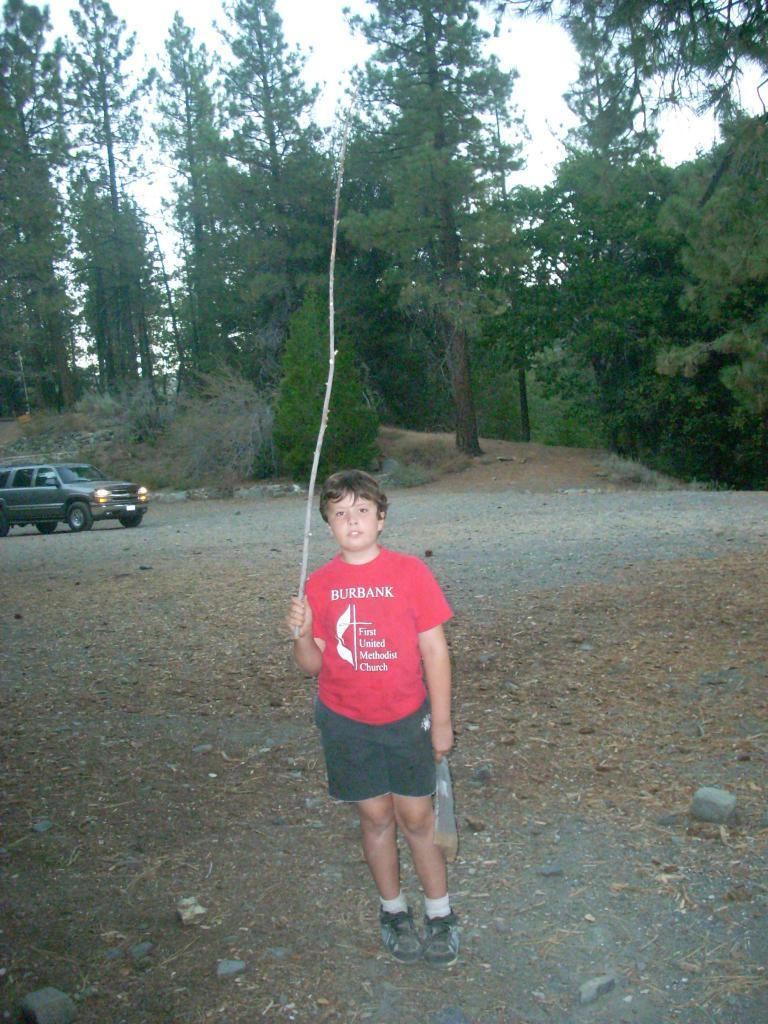What is the main subject of the image? The main subject of the image is a boy. What is the boy doing in the image? The boy is standing in the image. What is the boy holding in his hand? The boy is holding a stick in his hand. What else can be seen in the image besides the boy? There are stones, a car, trees, the ground, and the sky visible in the image. What type of rail can be seen in the image? There is no rail present in the image. What color is the vest the boy is wearing in the image? The boy is not wearing a vest in the image. 